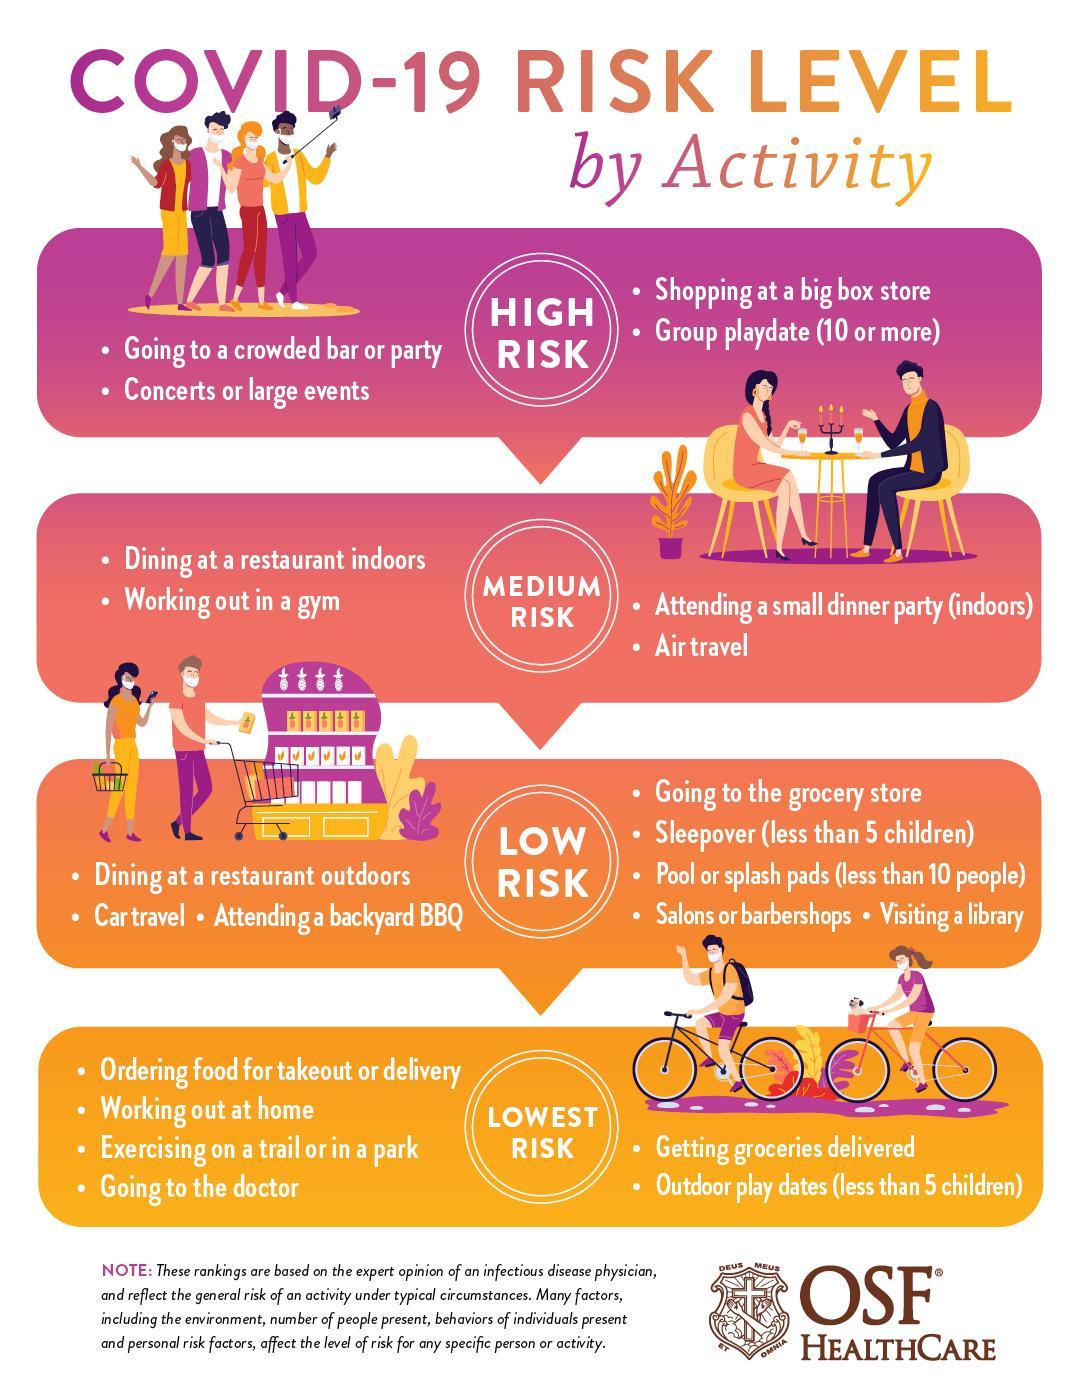In which risk category of COVID-19 does the 'air travel' belongs to?
Answer the question with a short phrase. MEDIUM RISK In which risk category of COVID-19 does the 'concerts or large events' belong to? HIGH RISK In which risk category of COVID-19 does the 'dinning at a restaurant outdoors' belongs to? LOW RISK In which risk category of COVID-19 does the 'working out at home' belongs to? LOWEST RISK 